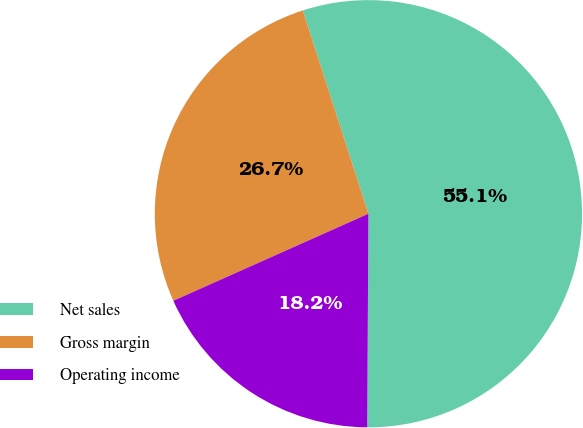Convert chart to OTSL. <chart><loc_0><loc_0><loc_500><loc_500><pie_chart><fcel>Net sales<fcel>Gross margin<fcel>Operating income<nl><fcel>55.06%<fcel>26.71%<fcel>18.23%<nl></chart> 